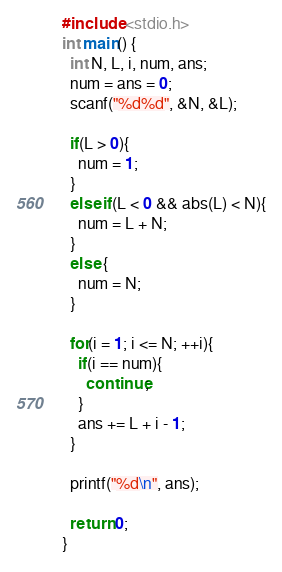Convert code to text. <code><loc_0><loc_0><loc_500><loc_500><_C_>#include <stdio.h>
int main() {
  int N, L, i, num, ans;
  num = ans = 0;
  scanf("%d%d", &N, &L);
  
  if(L > 0){
    num = 1;
  }
  else if(L < 0 && abs(L) < N){
    num = L + N;
  }
  else {
    num = N;
  }
  
  for(i = 1; i <= N; ++i){
    if(i == num){
      continue;
    }
    ans += L + i - 1;
  }
  
  printf("%d\n", ans);
  
  return 0;
}</code> 